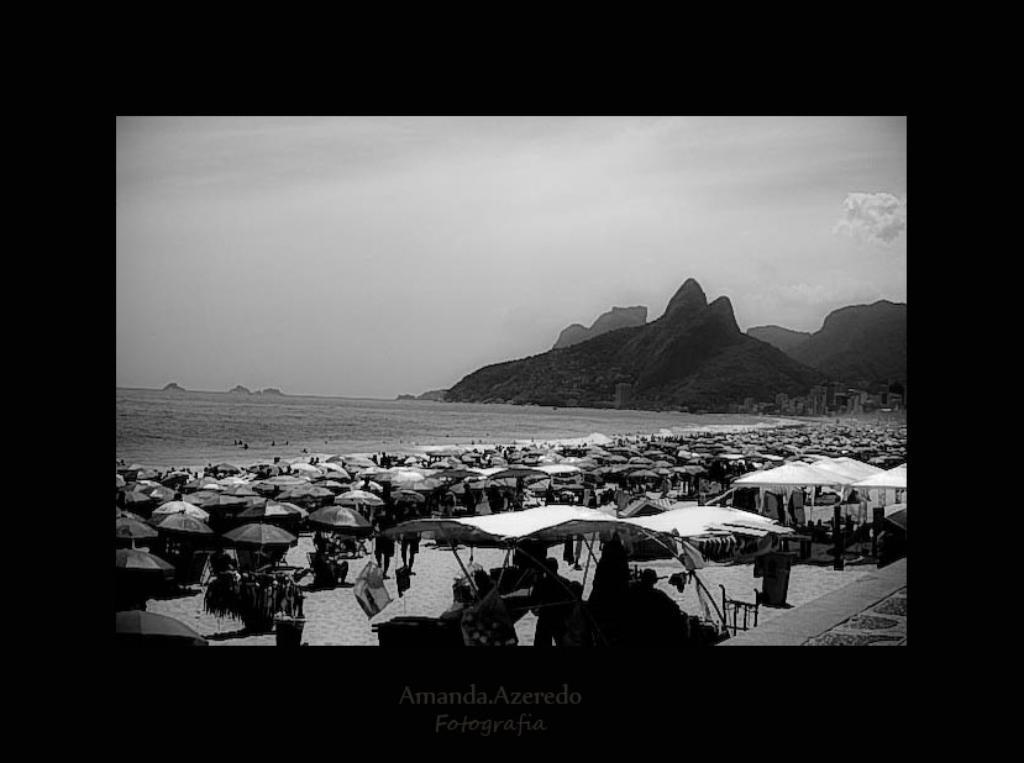How would you summarize this image in a sentence or two? In this picture we can see few tents, umbrellas and group of people, in the background we can see water, few hills and clouds, at the bottom of the image we can find some text. 